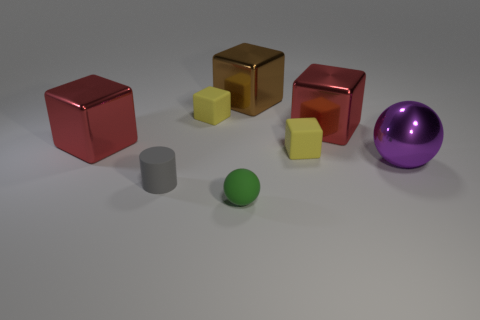There is a yellow cube behind the red metallic block right of the brown cube; how big is it?
Provide a short and direct response. Small. There is a purple shiny sphere; how many small cubes are behind it?
Keep it short and to the point. 2. The green rubber thing has what size?
Your response must be concise. Small. Is the material of the red cube to the right of the matte cylinder the same as the sphere left of the big purple shiny sphere?
Offer a terse response. No. Is there a shiny sphere of the same color as the small cylinder?
Offer a very short reply. No. There is a sphere that is the same size as the gray rubber cylinder; what is its color?
Ensure brevity in your answer.  Green. Is the color of the big shiny cube that is to the right of the brown cube the same as the matte sphere?
Ensure brevity in your answer.  No. Are there any big green cylinders that have the same material as the big purple object?
Provide a short and direct response. No. Are there fewer large brown metal cubes on the left side of the matte ball than small rubber blocks?
Give a very brief answer. Yes. There is a sphere that is in front of the purple sphere; does it have the same size as the gray rubber cylinder?
Provide a succinct answer. Yes. 